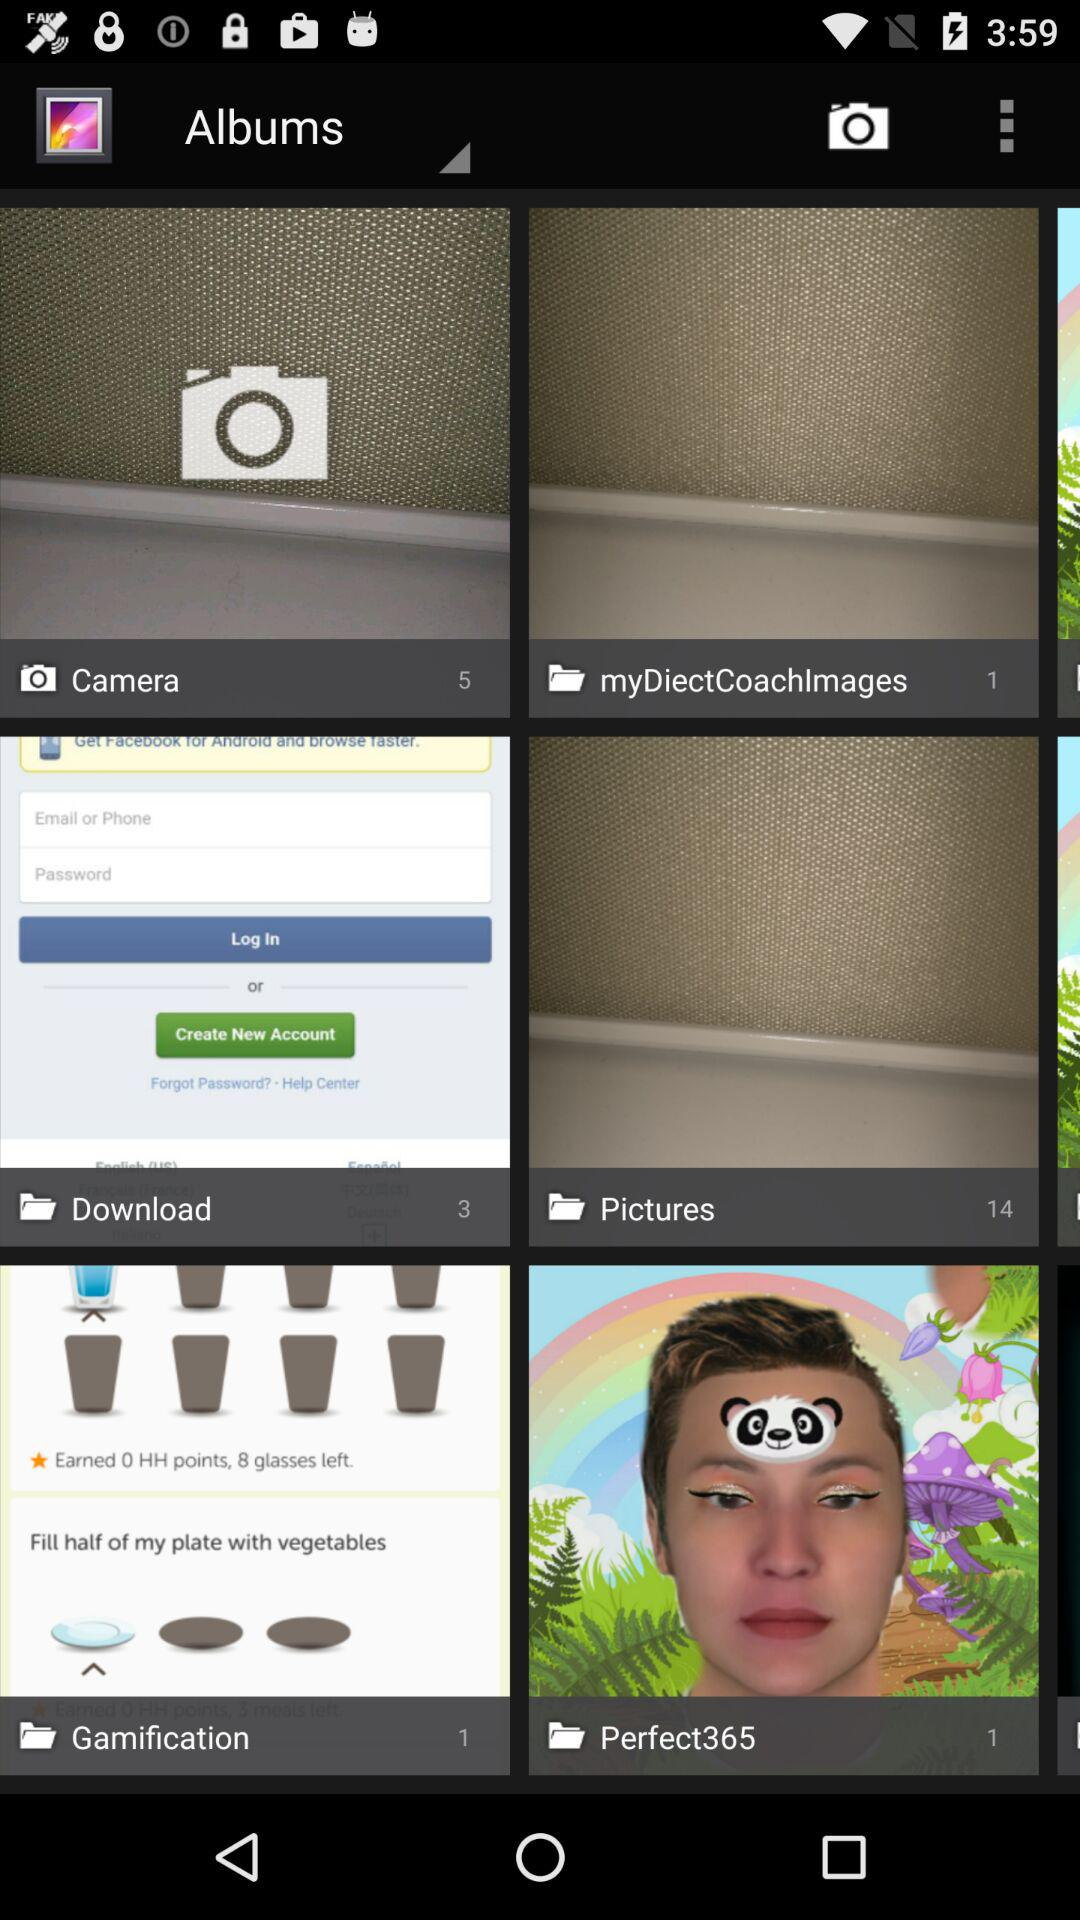How many photos are in a folder named "Pictures"? There are 14 photos. 